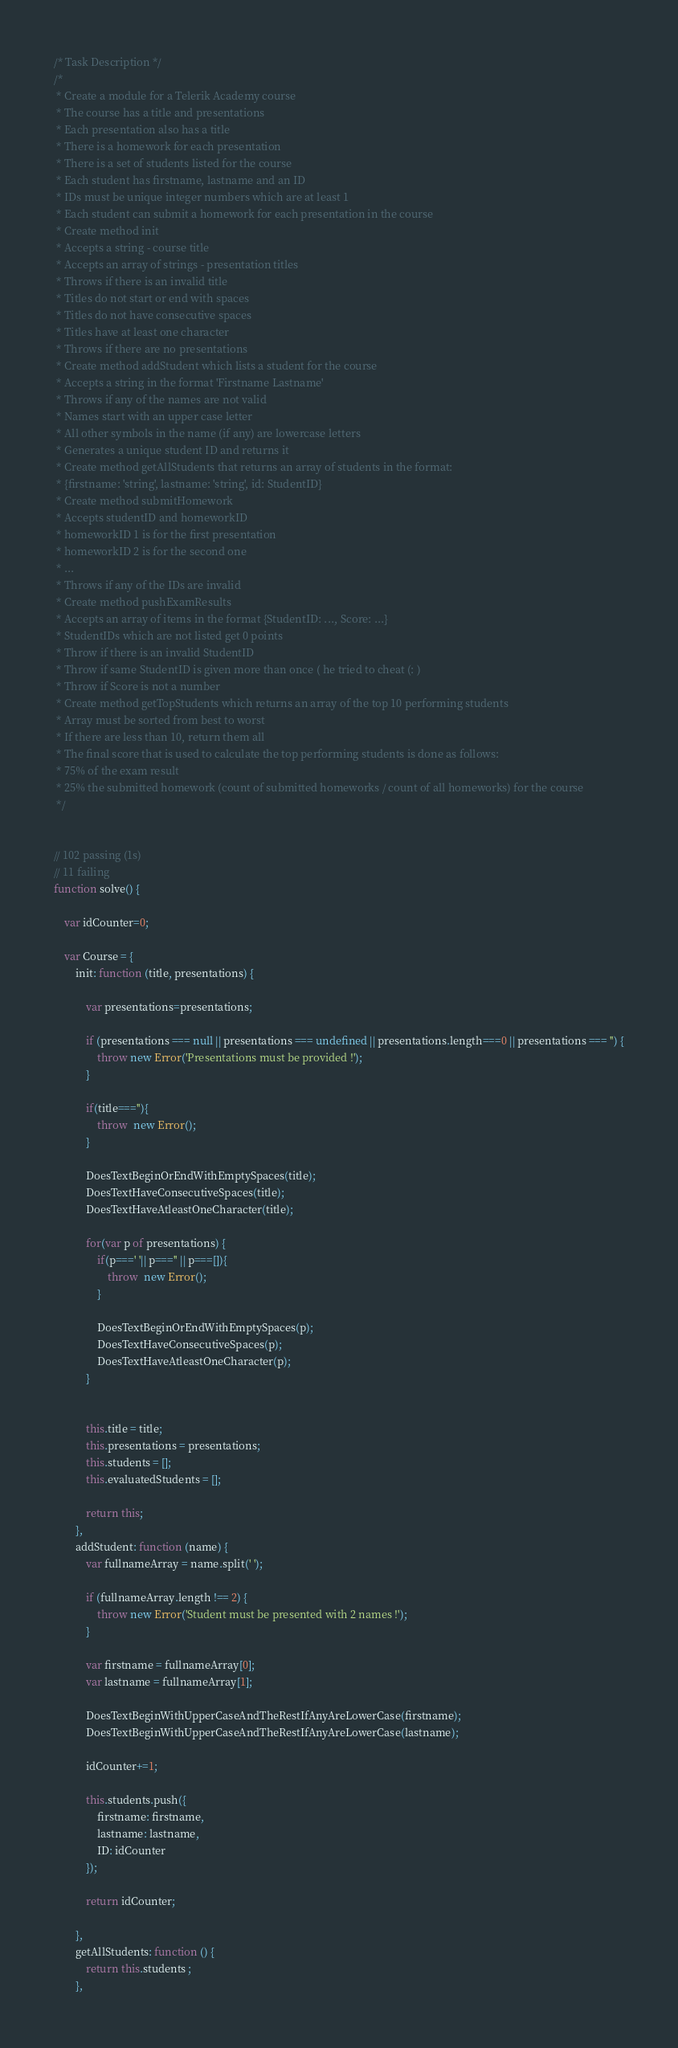<code> <loc_0><loc_0><loc_500><loc_500><_JavaScript_>/* Task Description */
/* 
 * Create a module for a Telerik Academy course
 * The course has a title and presentations
 * Each presentation also has a title
 * There is a homework for each presentation
 * There is a set of students listed for the course
 * Each student has firstname, lastname and an ID
 * IDs must be unique integer numbers which are at least 1
 * Each student can submit a homework for each presentation in the course
 * Create method init
 * Accepts a string - course title
 * Accepts an array of strings - presentation titles
 * Throws if there is an invalid title
 * Titles do not start or end with spaces
 * Titles do not have consecutive spaces
 * Titles have at least one character
 * Throws if there are no presentations
 * Create method addStudent which lists a student for the course
 * Accepts a string in the format 'Firstname Lastname'
 * Throws if any of the names are not valid
 * Names start with an upper case letter
 * All other symbols in the name (if any) are lowercase letters
 * Generates a unique student ID and returns it
 * Create method getAllStudents that returns an array of students in the format:
 * {firstname: 'string', lastname: 'string', id: StudentID}
 * Create method submitHomework
 * Accepts studentID and homeworkID
 * homeworkID 1 is for the first presentation
 * homeworkID 2 is for the second one
 * ...
 * Throws if any of the IDs are invalid
 * Create method pushExamResults
 * Accepts an array of items in the format {StudentID: ..., Score: ...}
 * StudentIDs which are not listed get 0 points
 * Throw if there is an invalid StudentID
 * Throw if same StudentID is given more than once ( he tried to cheat (: )
 * Throw if Score is not a number
 * Create method getTopStudents which returns an array of the top 10 performing students
 * Array must be sorted from best to worst
 * If there are less than 10, return them all
 * The final score that is used to calculate the top performing students is done as follows:
 * 75% of the exam result
 * 25% the submitted homework (count of submitted homeworks / count of all homeworks) for the course
 */


// 102 passing (1s)
// 11 failing
function solve() {

    var idCounter=0;

    var Course = {
        init: function (title, presentations) {

            var presentations=presentations;

            if (presentations === null || presentations === undefined || presentations.length===0 || presentations === '') {
                throw new Error('Presentations must be provided !');
            }

            if(title===''){
                throw  new Error();
            }

            DoesTextBeginOrEndWithEmptySpaces(title);
            DoesTextHaveConsecutiveSpaces(title);
            DoesTextHaveAtleastOneCharacter(title);

            for(var p of presentations) {
                if(p===' '|| p==='' || p===[]){
                    throw  new Error();
                }

                DoesTextBeginOrEndWithEmptySpaces(p);
                DoesTextHaveConsecutiveSpaces(p);
                DoesTextHaveAtleastOneCharacter(p);
            }


            this.title = title;
            this.presentations = presentations;
            this.students = [];
            this.evaluatedStudents = [];

            return this;
        },
        addStudent: function (name) {
            var fullnameArray = name.split(' ');

            if (fullnameArray.length !== 2) {
                throw new Error('Student must be presented with 2 names !');
            }

            var firstname = fullnameArray[0];
            var lastname = fullnameArray[1];

            DoesTextBeginWithUpperCaseAndTheRestIfAnyAreLowerCase(firstname);
            DoesTextBeginWithUpperCaseAndTheRestIfAnyAreLowerCase(lastname);

            idCounter+=1;

            this.students.push({
                firstname: firstname,
                lastname: lastname,
                ID: idCounter
            });

            return idCounter;

        },
        getAllStudents: function () {
            return this.students ;
        },</code> 